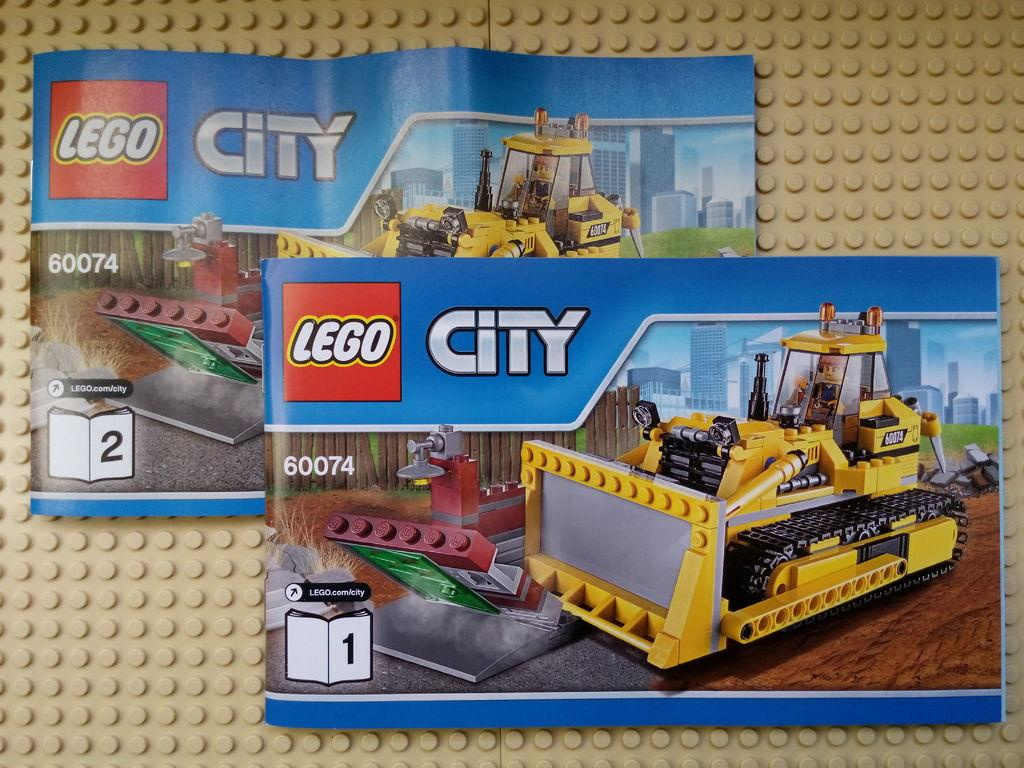How many posters are visible in the image? There are two posters in the image. What is mentioned on the first poster? The first poster has "Lego city" mentioned on it. What is mentioned on the second poster? The second poster has a "puzzle toy equipment of mud removing machine" mentioned on it. What type of clouds are depicted on the posters? There are no clouds depicted on the posters; they feature text about Lego city and a puzzle toy. 